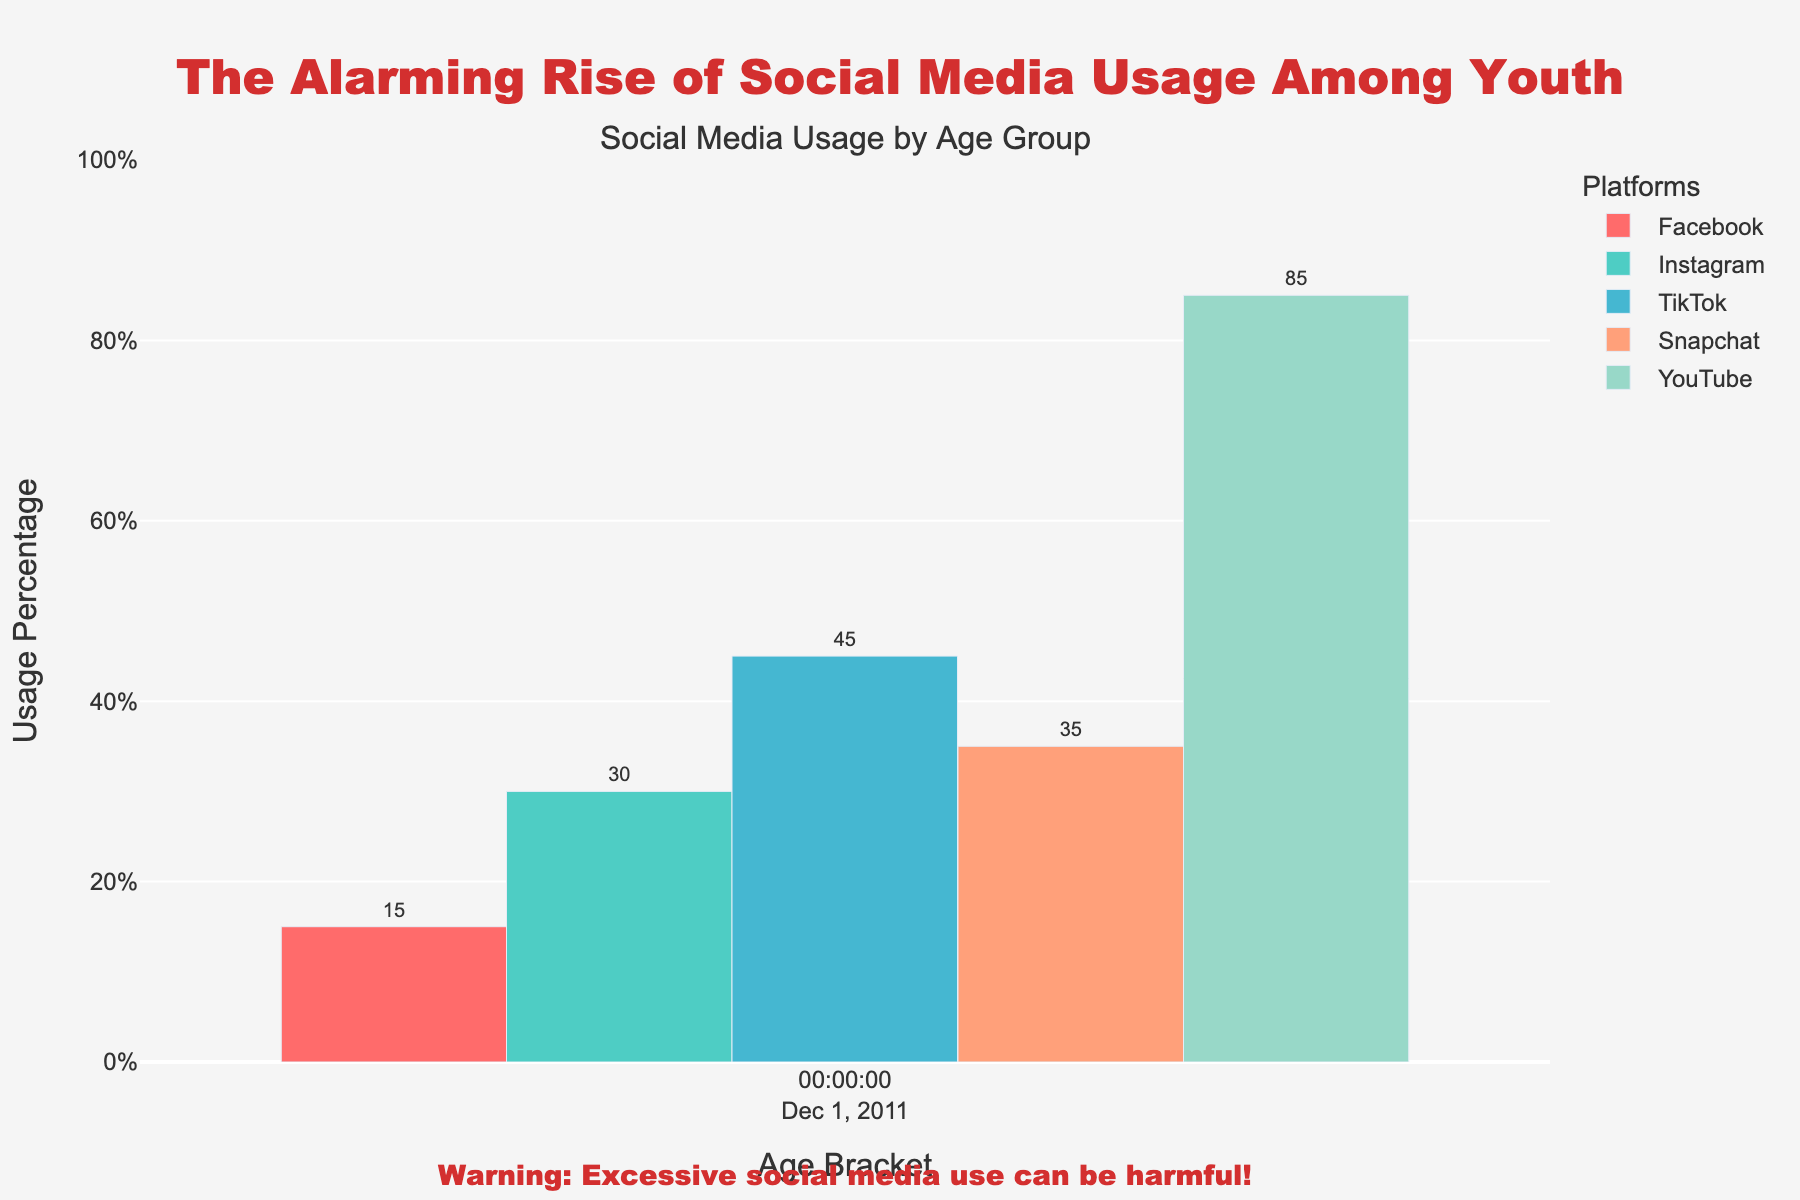Which age bracket has the highest usage of TikTok? From the chart, look at the height of the bars representing TikTok usage across different age brackets. The age bracket with the highest bar for TikTok usage is 15-16 years.
Answer: 15-16 Compare the usage of Snapchat between the 13-14 and 15-16 age brackets. Which one is higher? From the chart, observe the bars for Snapchat usage in the 13-14 and 15-16 age brackets. The 15-16 age bracket has a higher bar compared to the 13-14 age bracket.
Answer: 15-16 What is the difference in Facebook usage between the 17-18 and 8-10 age brackets? From the chart, identify the height of the Facebook bars for the 17-18 and 8-10 age brackets. Subtract the 8-10 value (5%) from the 17-18 value (65%). 65% - 5% = 60%.
Answer: 60% Which platform shows the highest usage across all age brackets? Looking at the chart, identify the bars with consistently high values across all age brackets. YouTube has the highest bars across all age brackets.
Answer: YouTube Does TikTok usage increase or decrease from the 15-16 to the 17-18 age bracket? Check the TikTok bars for the 15-16 and 17-18 age brackets. The 15-16 age bracket has a higher bar (75%) than the 17-18 age bracket (65%), indicating a decrease.
Answer: Decrease What is the average Instagram usage for all age brackets? Identify the Instagram values for all age brackets: 10, 30, 60, 75, 80. Sum these values: 10 + 30 + 60 + 75 + 80 = 255. Then divide by the number of age brackets (5): 255 / 5 = 51%.
Answer: 51% Which platform shows the most significant increase in usage from the 8-10 to the 11-12 age bracket? Compare the differences in usage percentages for all platforms between the 8-10 and 11-12 age brackets. TikTok shows the most significant increase, from 25% to 45%, which is a 20% increase.
Answer: TikTok Is Snapchat usage greater for the 8-10 age bracket or Instagram usage for the same bracket? Directly compare the heights of the bars for Snapchat and Instagram in the 8-10 age bracket. Snapchat has 15% and Instagram has 10%.
Answer: Snapchat What is the combined usage of Snapchat and Facebook for the 13-14 age bracket? Identify the Snapchat and Facebook values for the 13-14 age bracket: 65% and 35%, respectively. Sum these values: 65 + 35 = 100%.
Answer: 100 Among the 11-12 age bracket, which platform has the lowest usage, and what is its value? Observe the heights of the bars for all platforms in the 11-12 age bracket. Facebook has the lowest value at 15%.
Answer: Facebook, 15% 